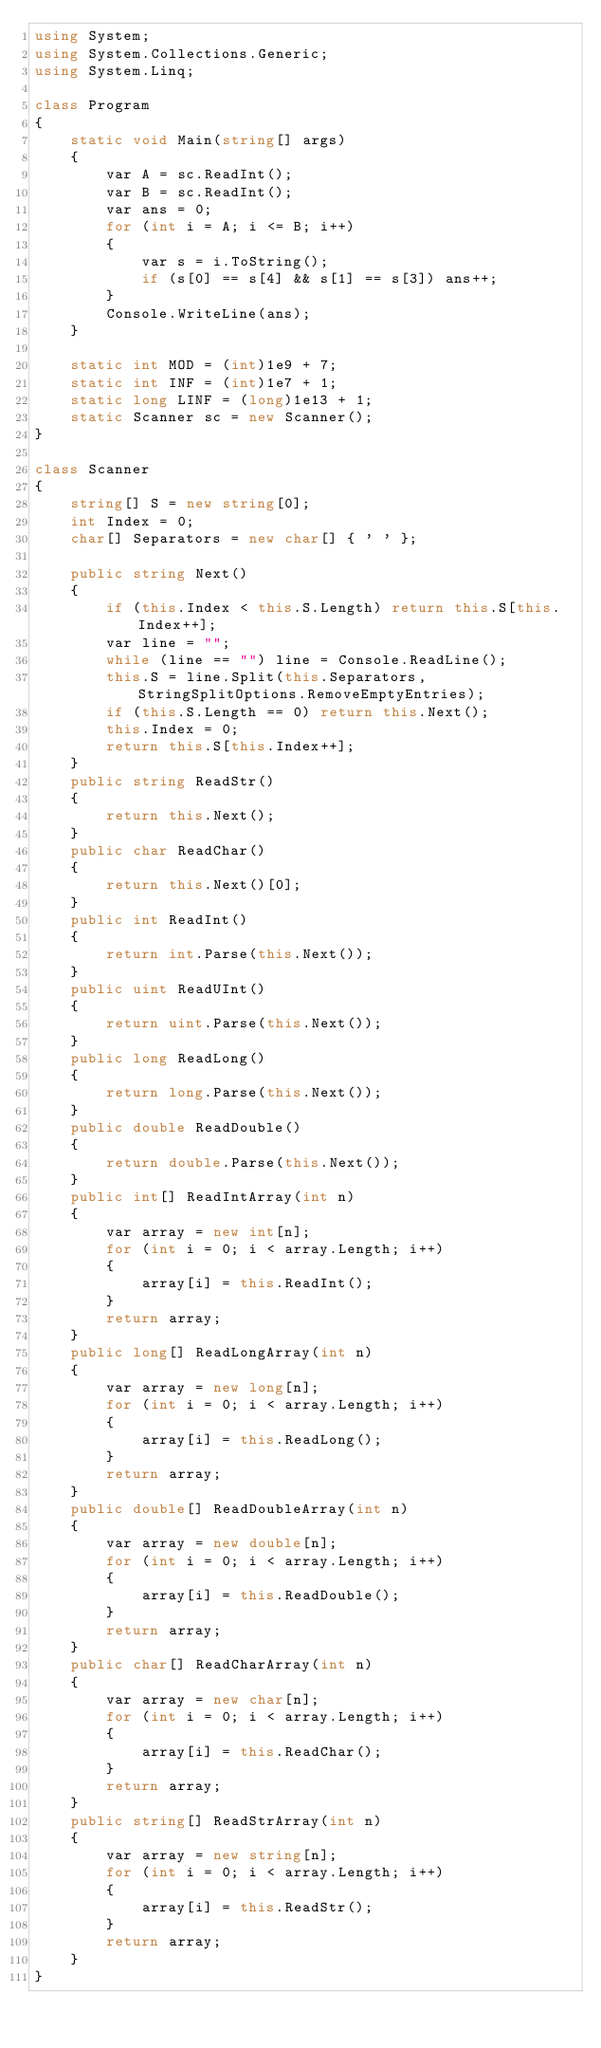Convert code to text. <code><loc_0><loc_0><loc_500><loc_500><_C#_>using System;
using System.Collections.Generic;
using System.Linq;

class Program
{
    static void Main(string[] args)
    {
        var A = sc.ReadInt();
        var B = sc.ReadInt();
        var ans = 0;
        for (int i = A; i <= B; i++)
        {
            var s = i.ToString();
            if (s[0] == s[4] && s[1] == s[3]) ans++;
        }
        Console.WriteLine(ans);
    }

    static int MOD = (int)1e9 + 7;
    static int INF = (int)1e7 + 1;
    static long LINF = (long)1e13 + 1;
    static Scanner sc = new Scanner();
}

class Scanner
{
    string[] S = new string[0];
    int Index = 0;
    char[] Separators = new char[] { ' ' };

    public string Next()
    {
        if (this.Index < this.S.Length) return this.S[this.Index++];
        var line = "";
        while (line == "") line = Console.ReadLine();
        this.S = line.Split(this.Separators, StringSplitOptions.RemoveEmptyEntries);
        if (this.S.Length == 0) return this.Next();
        this.Index = 0;
        return this.S[this.Index++];
    }
    public string ReadStr()
    {
        return this.Next();
    }
    public char ReadChar()
    {
        return this.Next()[0];
    }
    public int ReadInt()
    {
        return int.Parse(this.Next());
    }
    public uint ReadUInt()
    {
        return uint.Parse(this.Next());
    }
    public long ReadLong()
    {
        return long.Parse(this.Next());
    }
    public double ReadDouble()
    {
        return double.Parse(this.Next());
    }
    public int[] ReadIntArray(int n)
    {
        var array = new int[n];
        for (int i = 0; i < array.Length; i++)
        {
            array[i] = this.ReadInt();
        }
        return array;
    }
    public long[] ReadLongArray(int n)
    {
        var array = new long[n];
        for (int i = 0; i < array.Length; i++)
        {
            array[i] = this.ReadLong();
        }
        return array;
    }
    public double[] ReadDoubleArray(int n)
    {
        var array = new double[n];
        for (int i = 0; i < array.Length; i++)
        {
            array[i] = this.ReadDouble();
        }
        return array;
    }
    public char[] ReadCharArray(int n)
    {
        var array = new char[n];
        for (int i = 0; i < array.Length; i++)
        {
            array[i] = this.ReadChar();
        }
        return array;
    }
    public string[] ReadStrArray(int n)
    {
        var array = new string[n];
        for (int i = 0; i < array.Length; i++)
        {
            array[i] = this.ReadStr();
        }
        return array;
    }
}
</code> 